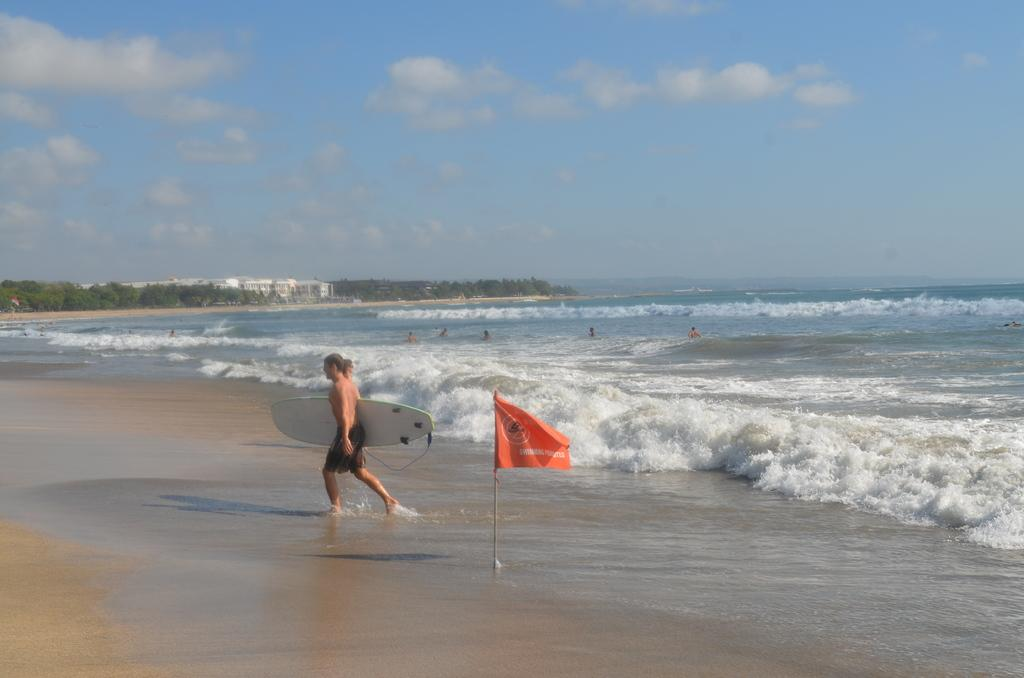What is the person in the image doing? The person is walking. What object is the person holding while walking? The person is holding a skateboard. What can be seen in the distance behind the person? There is a sea, sky, and trees visible in the background of the image. What type of vegetable is growing on the skateboard in the image? There is no vegetable growing on the skateboard in the image. What sound can be heard from the bells in the image? There are no bells present in the image. 